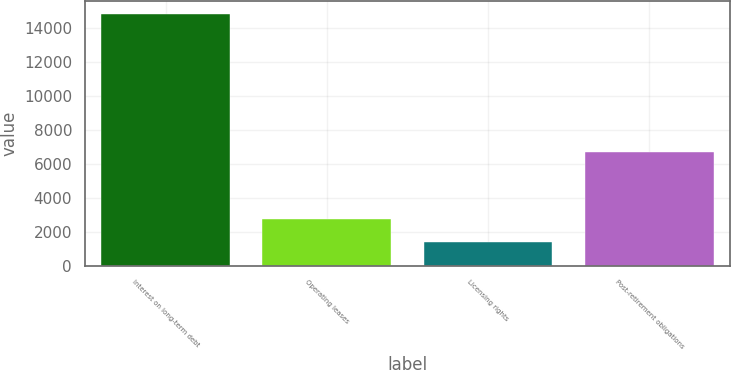Convert chart. <chart><loc_0><loc_0><loc_500><loc_500><bar_chart><fcel>Interest on long-term debt<fcel>Operating leases<fcel>Licensing rights<fcel>Post-retirement obligations<nl><fcel>14843<fcel>2721.8<fcel>1375<fcel>6678<nl></chart> 